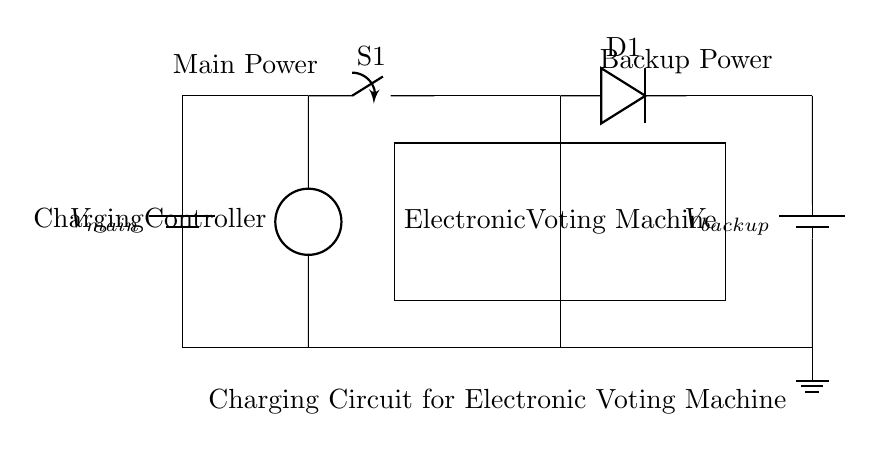What is the main power supply voltage? The circuit diagram does not specify an exact numerical value for the main power supply; it is labeled as V_main, indicating the source of power.
Answer: V_main What is the function of the charging controller? The charging controller's role is to regulate the flow of electricity to ensure that the Electronic Voting Machine is charged properly from the main power while also facilitating backup power as needed.
Answer: Regulate charging How many batteries are in the circuit? There are two batteries shown in the circuit: one for the main power supply and one as a backup. This identifies the dual power supply feature of the circuit.
Answer: Two batteries What component allows current to flow only in one direction? The component that allows current to flow only in one direction is labeled as D1, which is a diode. Its function is designed to prevent backflow of current, crucial for charging applications.
Answer: Diode Which component can be used to toggle the connection to the Electronic Voting Machine? The component labeled S1 is a switch, which can be opened or closed to connect or disconnect the main power to the Electronic Voting Machine. This functionality is essential for managing power sources effectively.
Answer: Switch What happens if both power supplies are active? If both power supplies are active, the circuit design with the diode (D1) ensures that the main power (V_main) charges the Electronic Voting Machine, while also allowing the backup battery (V_backup) to support it if needed, providing redundancy in power supply management.
Answer: Main power charges 